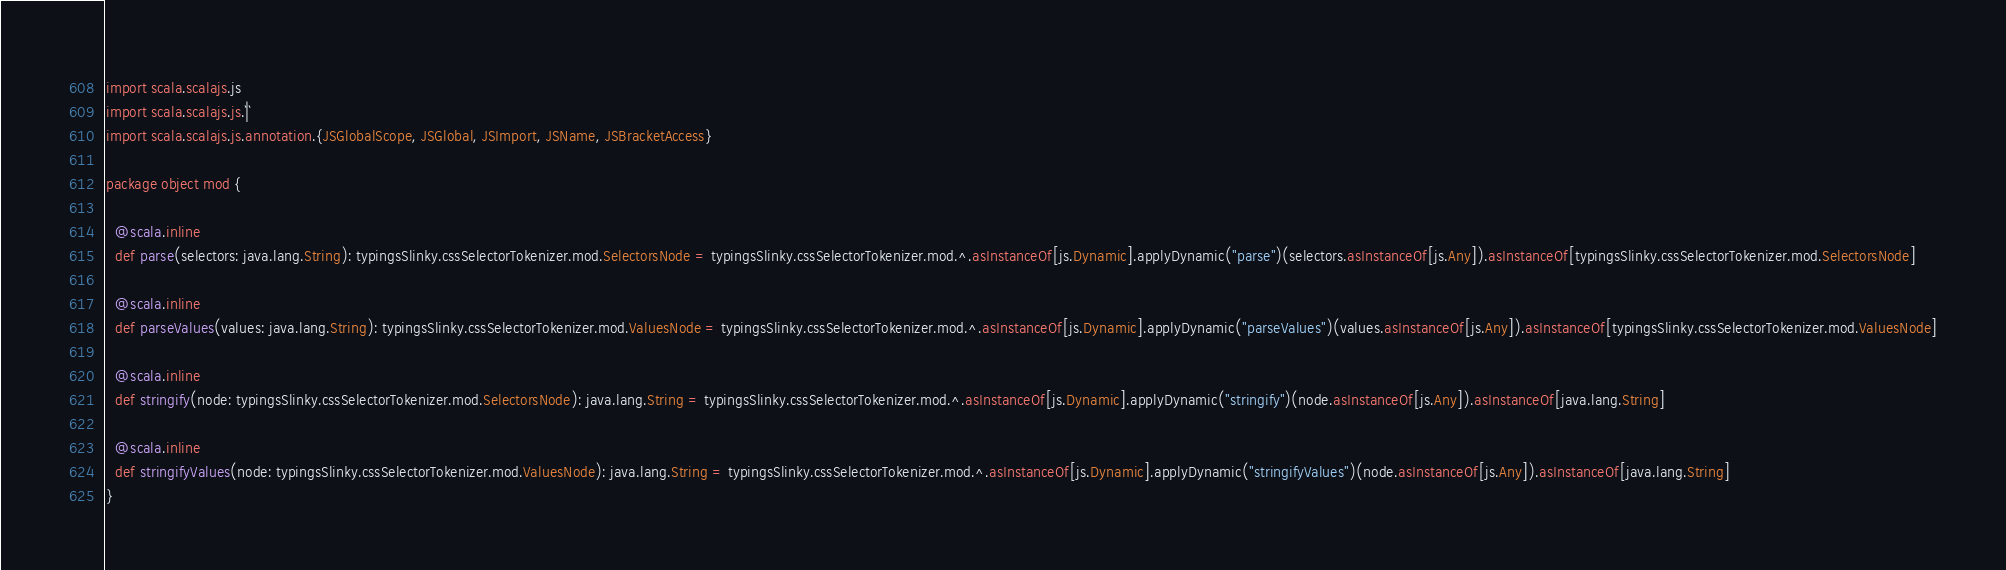<code> <loc_0><loc_0><loc_500><loc_500><_Scala_>import scala.scalajs.js
import scala.scalajs.js.`|`
import scala.scalajs.js.annotation.{JSGlobalScope, JSGlobal, JSImport, JSName, JSBracketAccess}

package object mod {
  
  @scala.inline
  def parse(selectors: java.lang.String): typingsSlinky.cssSelectorTokenizer.mod.SelectorsNode = typingsSlinky.cssSelectorTokenizer.mod.^.asInstanceOf[js.Dynamic].applyDynamic("parse")(selectors.asInstanceOf[js.Any]).asInstanceOf[typingsSlinky.cssSelectorTokenizer.mod.SelectorsNode]
  
  @scala.inline
  def parseValues(values: java.lang.String): typingsSlinky.cssSelectorTokenizer.mod.ValuesNode = typingsSlinky.cssSelectorTokenizer.mod.^.asInstanceOf[js.Dynamic].applyDynamic("parseValues")(values.asInstanceOf[js.Any]).asInstanceOf[typingsSlinky.cssSelectorTokenizer.mod.ValuesNode]
  
  @scala.inline
  def stringify(node: typingsSlinky.cssSelectorTokenizer.mod.SelectorsNode): java.lang.String = typingsSlinky.cssSelectorTokenizer.mod.^.asInstanceOf[js.Dynamic].applyDynamic("stringify")(node.asInstanceOf[js.Any]).asInstanceOf[java.lang.String]
  
  @scala.inline
  def stringifyValues(node: typingsSlinky.cssSelectorTokenizer.mod.ValuesNode): java.lang.String = typingsSlinky.cssSelectorTokenizer.mod.^.asInstanceOf[js.Dynamic].applyDynamic("stringifyValues")(node.asInstanceOf[js.Any]).asInstanceOf[java.lang.String]
}
</code> 